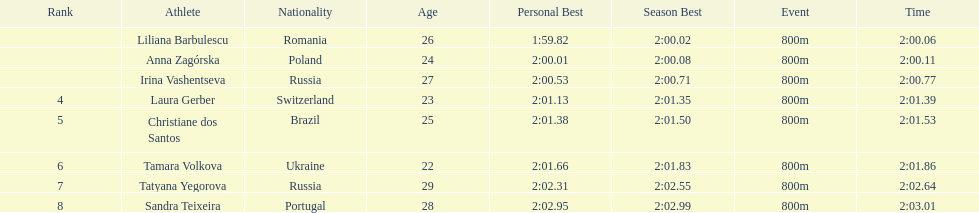The last runner crossed the finish line in 2:03.01. what was the previous time for the 7th runner? 2:02.64. 